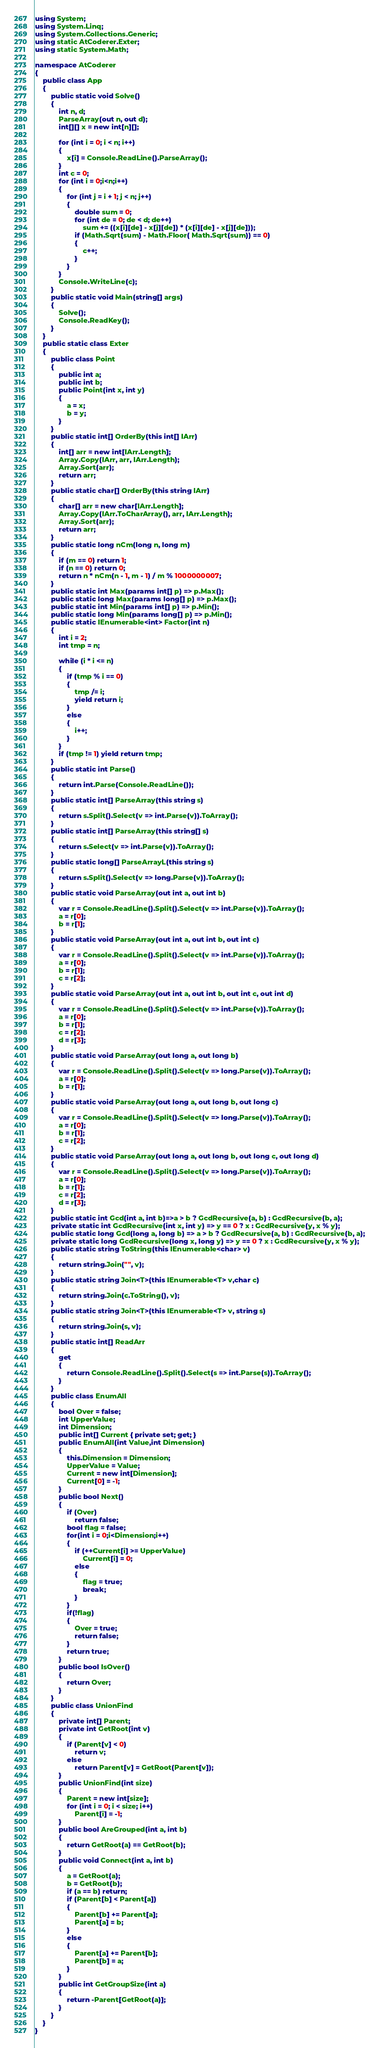<code> <loc_0><loc_0><loc_500><loc_500><_C#_>using System;
using System.Linq;
using System.Collections.Generic;
using static AtCoderer.Exter;
using static System.Math;

namespace AtCoderer
{
    public class App
    {
        public static void Solve()
        {
            int n, d;
            ParseArray(out n, out d);
            int[][] x = new int[n][];

            for (int i = 0; i < n; i++)
            {
                x[i] = Console.ReadLine().ParseArray();
            }
            int c = 0;
            for (int i = 0;i<n;i++)
            {
                for (int j = i + 1; j < n; j++)
                {
                    double sum = 0;
                    for (int de = 0; de < d; de++)
                        sum += ((x[i][de] - x[j][de]) * (x[i][de] - x[j][de]));
                    if (Math.Sqrt(sum) - Math.Floor( Math.Sqrt(sum)) == 0)
                    {
                        c++;
                    }
                }
            }
            Console.WriteLine(c);
        }
        public static void Main(string[] args)
        {
            Solve();
            Console.ReadKey();
        }
    }
    public static class Exter
    {
        public class Point
        {
            public int a;
            public int b;
            public Point(int x, int y)
            {
                a = x;
                b = y;
            }
        }
        public static int[] OrderBy(this int[] IArr)
        {
            int[] arr = new int[IArr.Length];
            Array.Copy(IArr, arr, IArr.Length);
            Array.Sort(arr);
            return arr;
        }
        public static char[] OrderBy(this string IArr)
        {
            char[] arr = new char[IArr.Length];
            Array.Copy(IArr.ToCharArray(), arr, IArr.Length);
            Array.Sort(arr);
            return arr;
        }
        public static long nCm(long n, long m)
        {
            if (m == 0) return 1;
            if (n == 0) return 0;
            return n * nCm(n - 1, m - 1) / m % 1000000007;
        }
        public static int Max(params int[] p) => p.Max();
        public static long Max(params long[] p) => p.Max();
        public static int Min(params int[] p) => p.Min();
        public static long Min(params long[] p) => p.Min();
        public static IEnumerable<int> Factor(int n)
        {
            int i = 2;
            int tmp = n;

            while (i * i <= n)
            {
                if (tmp % i == 0)
                {
                    tmp /= i;
                    yield return i;
                }
                else
                {
                    i++;
                }
            }
            if (tmp != 1) yield return tmp;
        }
        public static int Parse()
        {
            return int.Parse(Console.ReadLine());
        }
        public static int[] ParseArray(this string s)
        {
            return s.Split().Select(v => int.Parse(v)).ToArray();
        }
        public static int[] ParseArray(this string[] s)
        {
            return s.Select(v => int.Parse(v)).ToArray();
        }
        public static long[] ParseArrayL(this string s)
        {
            return s.Split().Select(v => long.Parse(v)).ToArray();
        }
        public static void ParseArray(out int a, out int b)
        {
            var r = Console.ReadLine().Split().Select(v => int.Parse(v)).ToArray();
            a = r[0];
            b = r[1];
        }
        public static void ParseArray(out int a, out int b, out int c)
        {
            var r = Console.ReadLine().Split().Select(v => int.Parse(v)).ToArray();
            a = r[0];
            b = r[1];
            c = r[2];
        }
        public static void ParseArray(out int a, out int b, out int c, out int d)
        {
            var r = Console.ReadLine().Split().Select(v => int.Parse(v)).ToArray();
            a = r[0];
            b = r[1];
            c = r[2];
            d = r[3];
        }
        public static void ParseArray(out long a, out long b)
        {
            var r = Console.ReadLine().Split().Select(v => long.Parse(v)).ToArray();
            a = r[0];
            b = r[1];
        }
        public static void ParseArray(out long a, out long b, out long c)
        {
            var r = Console.ReadLine().Split().Select(v => long.Parse(v)).ToArray();
            a = r[0];
            b = r[1];
            c = r[2];
        }
        public static void ParseArray(out long a, out long b, out long c, out long d)
        {
            var r = Console.ReadLine().Split().Select(v => long.Parse(v)).ToArray();
            a = r[0];
            b = r[1];
            c = r[2];
            d = r[3];
        }
        public static int Gcd(int a, int b)=>a > b ? GcdRecursive(a, b) : GcdRecursive(b, a);
        private static int GcdRecursive(int x, int y) => y == 0 ? x : GcdRecursive(y, x % y);
        public static long Gcd(long a, long b) => a > b ? GcdRecursive(a, b) : GcdRecursive(b, a);
        private static long GcdRecursive(long x, long y) => y == 0 ? x : GcdRecursive(y, x % y);
        public static string ToString(this IEnumerable<char> v)
        {
            return string.Join("", v);
        }
        public static string Join<T>(this IEnumerable<T> v,char c)
        {
            return string.Join(c.ToString(), v);
        }
        public static string Join<T>(this IEnumerable<T> v, string s)
        {
            return string.Join(s, v);
        }
        public static int[] ReadArr
        {
            get
            {
                return Console.ReadLine().Split().Select(s => int.Parse(s)).ToArray();
            }
        }
        public class EnumAll
        {
            bool Over = false;
            int UpperValue;
            int Dimension;
            public int[] Current { private set; get; }
            public EnumAll(int Value,int Dimension)
            {
                this.Dimension = Dimension;
                UpperValue = Value;
                Current = new int[Dimension];
                Current[0] = -1;
            }
            public bool Next()
            {
                if (Over)
                    return false;
                bool flag = false;
                for(int i = 0;i<Dimension;i++)
                {
                    if (++Current[i] >= UpperValue)
                        Current[i] = 0;
                    else
                    {
                        flag = true;
                        break;
                    }
                }
                if(!flag)
                {
                    Over = true;
                    return false;
                }
                return true;
            }
            public bool IsOver()
            {
                return Over;
            }
        }
        public class UnionFind
        {
            private int[] Parent;
            private int GetRoot(int v)
            {
                if (Parent[v] < 0)
                    return v;
                else
                    return Parent[v] = GetRoot(Parent[v]);
            }
            public UnionFind(int size)
            {
                Parent = new int[size];
                for (int i = 0; i < size; i++)
                    Parent[i] = -1;
            }
            public bool AreGrouped(int a, int b)
            {
                return GetRoot(a) == GetRoot(b);
            }
            public void Connect(int a, int b)
            {
                a = GetRoot(a);
                b = GetRoot(b);
                if (a == b) return;
                if (Parent[b] < Parent[a])
                {
                    Parent[b] += Parent[a];
                    Parent[a] = b;
                }
                else
                {
                    Parent[a] += Parent[b];
                    Parent[b] = a;
                }
            }
            public int GetGroupSize(int a)
            {
                return -Parent[GetRoot(a)];
            }
        }
    }
}
</code> 